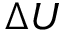<formula> <loc_0><loc_0><loc_500><loc_500>\Delta U</formula> 